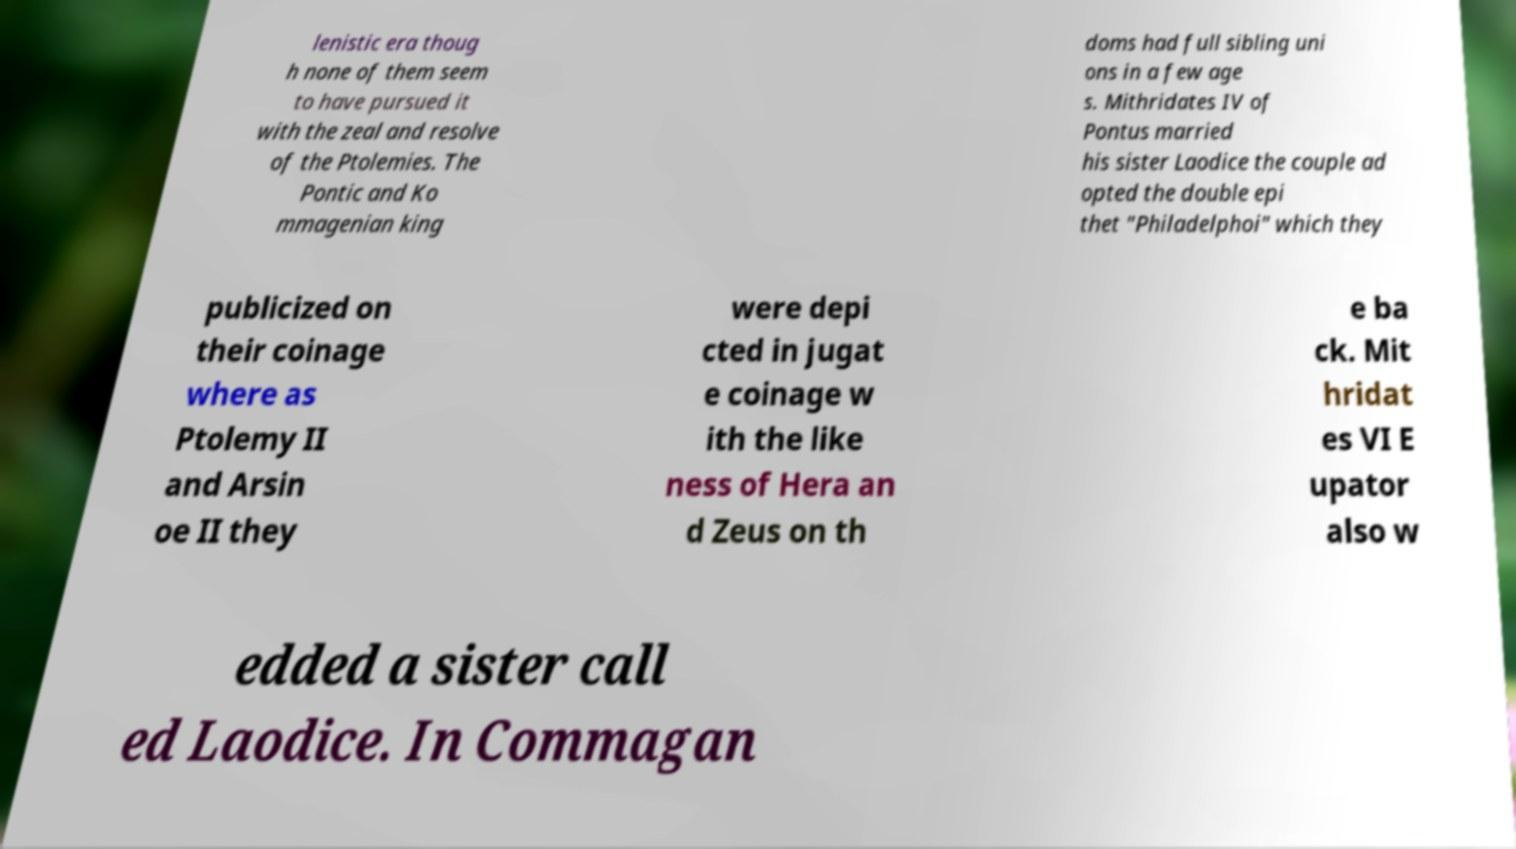For documentation purposes, I need the text within this image transcribed. Could you provide that? lenistic era thoug h none of them seem to have pursued it with the zeal and resolve of the Ptolemies. The Pontic and Ko mmagenian king doms had full sibling uni ons in a few age s. Mithridates IV of Pontus married his sister Laodice the couple ad opted the double epi thet "Philadelphoi" which they publicized on their coinage where as Ptolemy II and Arsin oe II they were depi cted in jugat e coinage w ith the like ness of Hera an d Zeus on th e ba ck. Mit hridat es VI E upator also w edded a sister call ed Laodice. In Commagan 